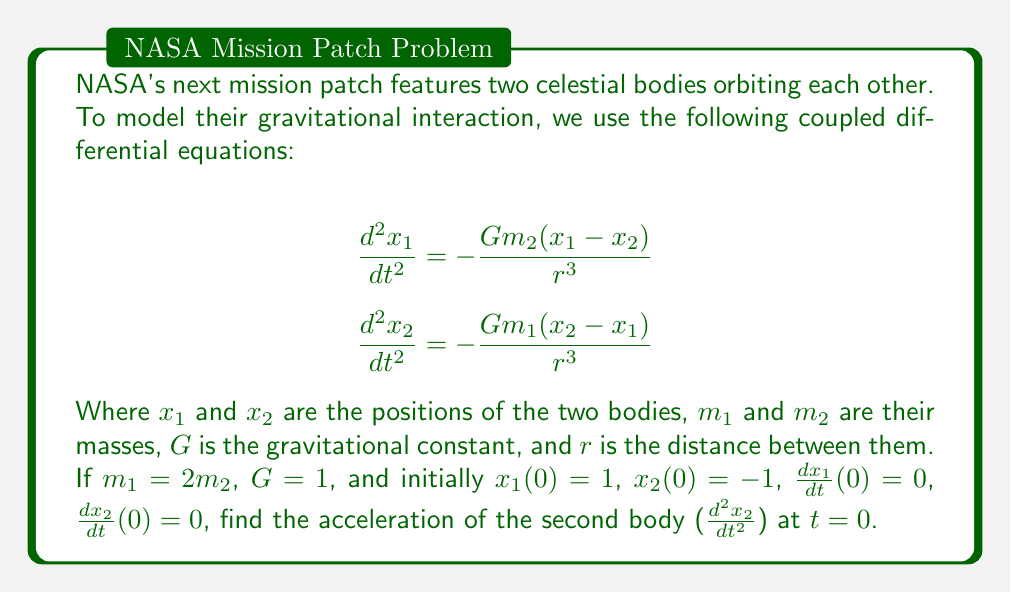Can you solve this math problem? Let's approach this step-by-step:

1) First, we need to calculate $r$, the initial distance between the bodies:
   $r = |x_1(0) - x_2(0)| = |1 - (-1)| = 2$

2) Now, we can substitute the given values into the equation for $\frac{d^2x_2}{dt^2}$:

   $$\frac{d^2x_2}{dt^2} = -\frac{Gm_1(x_2 - x_1)}{r^3}$$

3) We know that:
   - $G = 1$
   - $m_1 = 2m_2$ (we can use $m_2$ as our unit of mass, so $m_1 = 2$ and $m_2 = 1$)
   - $x_2(0) = -1$
   - $x_1(0) = 1$
   - $r = 2$

4) Substituting these values:

   $$\frac{d^2x_2}{dt^2} = -\frac{1 \cdot 2 \cdot (-1 - 1)}{2^3}$$

5) Simplifying:

   $$\frac{d^2x_2}{dt^2} = -\frac{2 \cdot (-2)}{8} = \frac{1}{2}$$

Therefore, the acceleration of the second body at $t = 0$ is $\frac{1}{2}$ in our chosen units.
Answer: $\frac{1}{2}$ 